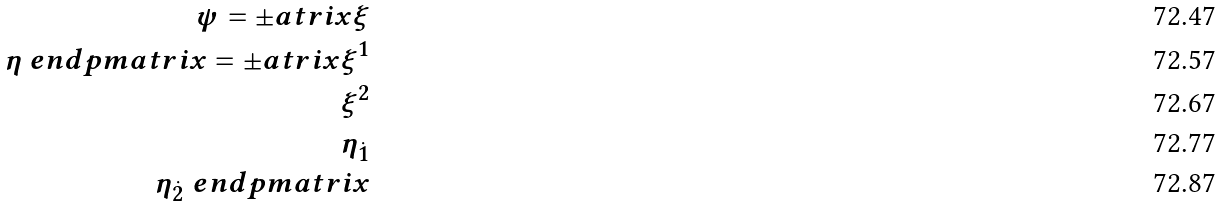<formula> <loc_0><loc_0><loc_500><loc_500>\psi = \pm a t r i x \xi \\ \eta \ e n d p m a t r i x = \pm a t r i x \xi ^ { 1 } \\ \xi ^ { 2 } \\ \eta _ { \dot { 1 } } \\ \eta _ { \dot { 2 } } \ e n d p m a t r i x</formula> 